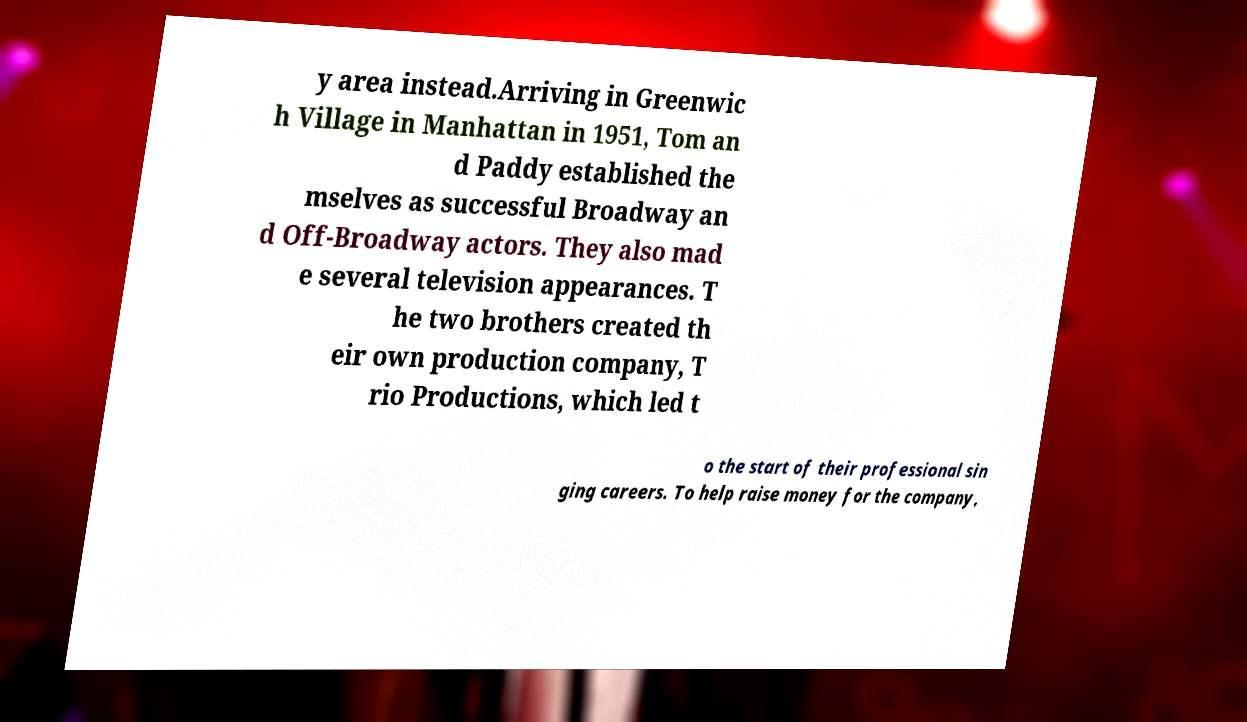There's text embedded in this image that I need extracted. Can you transcribe it verbatim? y area instead.Arriving in Greenwic h Village in Manhattan in 1951, Tom an d Paddy established the mselves as successful Broadway an d Off-Broadway actors. They also mad e several television appearances. T he two brothers created th eir own production company, T rio Productions, which led t o the start of their professional sin ging careers. To help raise money for the company, 